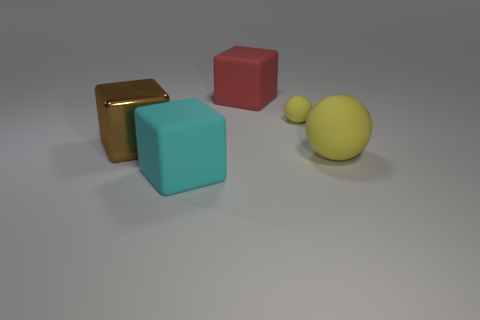Subtract all brown metal blocks. How many blocks are left? 2 Add 3 big cyan cubes. How many objects exist? 8 Subtract all blocks. How many objects are left? 2 Add 3 large brown objects. How many large brown objects exist? 4 Subtract 1 brown blocks. How many objects are left? 4 Subtract 1 balls. How many balls are left? 1 Subtract all cyan cubes. Subtract all red spheres. How many cubes are left? 2 Subtract all gray cylinders. Subtract all big brown blocks. How many objects are left? 4 Add 1 large matte blocks. How many large matte blocks are left? 3 